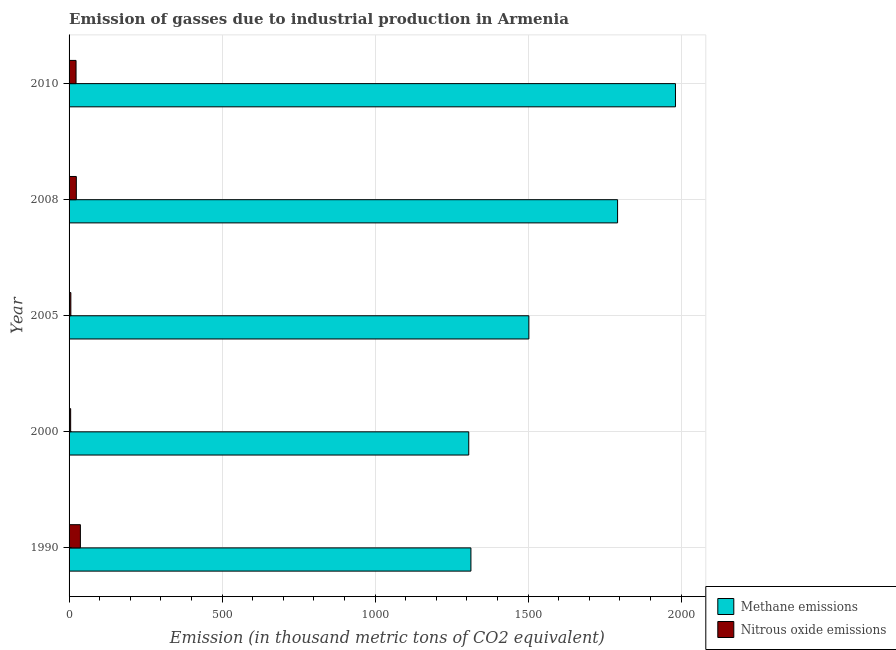How many different coloured bars are there?
Your answer should be compact. 2. Are the number of bars per tick equal to the number of legend labels?
Your answer should be compact. Yes. What is the label of the 2nd group of bars from the top?
Your answer should be very brief. 2008. In how many cases, is the number of bars for a given year not equal to the number of legend labels?
Offer a very short reply. 0. What is the amount of methane emissions in 2000?
Make the answer very short. 1306.1. Across all years, what is the maximum amount of methane emissions?
Keep it short and to the point. 1981.6. Across all years, what is the minimum amount of nitrous oxide emissions?
Give a very brief answer. 5.2. In which year was the amount of methane emissions minimum?
Offer a terse response. 2000. What is the total amount of methane emissions in the graph?
Ensure brevity in your answer.  7895.8. What is the difference between the amount of nitrous oxide emissions in 1990 and that in 2008?
Ensure brevity in your answer.  13.3. What is the difference between the amount of nitrous oxide emissions in 2005 and the amount of methane emissions in 2010?
Your response must be concise. -1975.8. What is the average amount of nitrous oxide emissions per year?
Your response must be concise. 18.9. In the year 2008, what is the difference between the amount of nitrous oxide emissions and amount of methane emissions?
Your response must be concise. -1768.7. What is the ratio of the amount of nitrous oxide emissions in 2008 to that in 2010?
Keep it short and to the point. 1.04. Is the difference between the amount of nitrous oxide emissions in 2000 and 2010 greater than the difference between the amount of methane emissions in 2000 and 2010?
Ensure brevity in your answer.  Yes. What is the difference between the highest and the second highest amount of nitrous oxide emissions?
Keep it short and to the point. 13.3. What is the difference between the highest and the lowest amount of methane emissions?
Give a very brief answer. 675.5. What does the 1st bar from the top in 2000 represents?
Give a very brief answer. Nitrous oxide emissions. What does the 1st bar from the bottom in 2005 represents?
Provide a succinct answer. Methane emissions. How many bars are there?
Your answer should be compact. 10. Are all the bars in the graph horizontal?
Your answer should be very brief. Yes. How many years are there in the graph?
Your answer should be compact. 5. Are the values on the major ticks of X-axis written in scientific E-notation?
Offer a terse response. No. Does the graph contain any zero values?
Your answer should be very brief. No. Does the graph contain grids?
Provide a succinct answer. Yes. Where does the legend appear in the graph?
Give a very brief answer. Bottom right. How many legend labels are there?
Offer a terse response. 2. How are the legend labels stacked?
Make the answer very short. Vertical. What is the title of the graph?
Your response must be concise. Emission of gasses due to industrial production in Armenia. Does "RDB concessional" appear as one of the legend labels in the graph?
Your answer should be compact. No. What is the label or title of the X-axis?
Provide a short and direct response. Emission (in thousand metric tons of CO2 equivalent). What is the label or title of the Y-axis?
Provide a short and direct response. Year. What is the Emission (in thousand metric tons of CO2 equivalent) of Methane emissions in 1990?
Keep it short and to the point. 1313.2. What is the Emission (in thousand metric tons of CO2 equivalent) in Methane emissions in 2000?
Provide a short and direct response. 1306.1. What is the Emission (in thousand metric tons of CO2 equivalent) of Methane emissions in 2005?
Offer a terse response. 1502.5. What is the Emission (in thousand metric tons of CO2 equivalent) of Methane emissions in 2008?
Provide a short and direct response. 1792.4. What is the Emission (in thousand metric tons of CO2 equivalent) of Nitrous oxide emissions in 2008?
Provide a short and direct response. 23.7. What is the Emission (in thousand metric tons of CO2 equivalent) of Methane emissions in 2010?
Make the answer very short. 1981.6. What is the Emission (in thousand metric tons of CO2 equivalent) in Nitrous oxide emissions in 2010?
Your answer should be very brief. 22.8. Across all years, what is the maximum Emission (in thousand metric tons of CO2 equivalent) of Methane emissions?
Your response must be concise. 1981.6. Across all years, what is the minimum Emission (in thousand metric tons of CO2 equivalent) in Methane emissions?
Offer a very short reply. 1306.1. Across all years, what is the minimum Emission (in thousand metric tons of CO2 equivalent) in Nitrous oxide emissions?
Offer a very short reply. 5.2. What is the total Emission (in thousand metric tons of CO2 equivalent) in Methane emissions in the graph?
Your answer should be very brief. 7895.8. What is the total Emission (in thousand metric tons of CO2 equivalent) in Nitrous oxide emissions in the graph?
Offer a terse response. 94.5. What is the difference between the Emission (in thousand metric tons of CO2 equivalent) of Methane emissions in 1990 and that in 2000?
Ensure brevity in your answer.  7.1. What is the difference between the Emission (in thousand metric tons of CO2 equivalent) in Nitrous oxide emissions in 1990 and that in 2000?
Keep it short and to the point. 31.8. What is the difference between the Emission (in thousand metric tons of CO2 equivalent) of Methane emissions in 1990 and that in 2005?
Your answer should be very brief. -189.3. What is the difference between the Emission (in thousand metric tons of CO2 equivalent) of Nitrous oxide emissions in 1990 and that in 2005?
Make the answer very short. 31.2. What is the difference between the Emission (in thousand metric tons of CO2 equivalent) of Methane emissions in 1990 and that in 2008?
Make the answer very short. -479.2. What is the difference between the Emission (in thousand metric tons of CO2 equivalent) of Methane emissions in 1990 and that in 2010?
Provide a short and direct response. -668.4. What is the difference between the Emission (in thousand metric tons of CO2 equivalent) of Nitrous oxide emissions in 1990 and that in 2010?
Give a very brief answer. 14.2. What is the difference between the Emission (in thousand metric tons of CO2 equivalent) in Methane emissions in 2000 and that in 2005?
Make the answer very short. -196.4. What is the difference between the Emission (in thousand metric tons of CO2 equivalent) in Methane emissions in 2000 and that in 2008?
Offer a very short reply. -486.3. What is the difference between the Emission (in thousand metric tons of CO2 equivalent) of Nitrous oxide emissions in 2000 and that in 2008?
Provide a succinct answer. -18.5. What is the difference between the Emission (in thousand metric tons of CO2 equivalent) in Methane emissions in 2000 and that in 2010?
Ensure brevity in your answer.  -675.5. What is the difference between the Emission (in thousand metric tons of CO2 equivalent) in Nitrous oxide emissions in 2000 and that in 2010?
Provide a succinct answer. -17.6. What is the difference between the Emission (in thousand metric tons of CO2 equivalent) of Methane emissions in 2005 and that in 2008?
Ensure brevity in your answer.  -289.9. What is the difference between the Emission (in thousand metric tons of CO2 equivalent) of Nitrous oxide emissions in 2005 and that in 2008?
Offer a terse response. -17.9. What is the difference between the Emission (in thousand metric tons of CO2 equivalent) in Methane emissions in 2005 and that in 2010?
Give a very brief answer. -479.1. What is the difference between the Emission (in thousand metric tons of CO2 equivalent) in Methane emissions in 2008 and that in 2010?
Your answer should be compact. -189.2. What is the difference between the Emission (in thousand metric tons of CO2 equivalent) in Methane emissions in 1990 and the Emission (in thousand metric tons of CO2 equivalent) in Nitrous oxide emissions in 2000?
Give a very brief answer. 1308. What is the difference between the Emission (in thousand metric tons of CO2 equivalent) in Methane emissions in 1990 and the Emission (in thousand metric tons of CO2 equivalent) in Nitrous oxide emissions in 2005?
Your answer should be very brief. 1307.4. What is the difference between the Emission (in thousand metric tons of CO2 equivalent) of Methane emissions in 1990 and the Emission (in thousand metric tons of CO2 equivalent) of Nitrous oxide emissions in 2008?
Provide a short and direct response. 1289.5. What is the difference between the Emission (in thousand metric tons of CO2 equivalent) of Methane emissions in 1990 and the Emission (in thousand metric tons of CO2 equivalent) of Nitrous oxide emissions in 2010?
Your answer should be compact. 1290.4. What is the difference between the Emission (in thousand metric tons of CO2 equivalent) of Methane emissions in 2000 and the Emission (in thousand metric tons of CO2 equivalent) of Nitrous oxide emissions in 2005?
Keep it short and to the point. 1300.3. What is the difference between the Emission (in thousand metric tons of CO2 equivalent) in Methane emissions in 2000 and the Emission (in thousand metric tons of CO2 equivalent) in Nitrous oxide emissions in 2008?
Your answer should be compact. 1282.4. What is the difference between the Emission (in thousand metric tons of CO2 equivalent) in Methane emissions in 2000 and the Emission (in thousand metric tons of CO2 equivalent) in Nitrous oxide emissions in 2010?
Keep it short and to the point. 1283.3. What is the difference between the Emission (in thousand metric tons of CO2 equivalent) of Methane emissions in 2005 and the Emission (in thousand metric tons of CO2 equivalent) of Nitrous oxide emissions in 2008?
Make the answer very short. 1478.8. What is the difference between the Emission (in thousand metric tons of CO2 equivalent) of Methane emissions in 2005 and the Emission (in thousand metric tons of CO2 equivalent) of Nitrous oxide emissions in 2010?
Give a very brief answer. 1479.7. What is the difference between the Emission (in thousand metric tons of CO2 equivalent) in Methane emissions in 2008 and the Emission (in thousand metric tons of CO2 equivalent) in Nitrous oxide emissions in 2010?
Ensure brevity in your answer.  1769.6. What is the average Emission (in thousand metric tons of CO2 equivalent) in Methane emissions per year?
Your answer should be very brief. 1579.16. In the year 1990, what is the difference between the Emission (in thousand metric tons of CO2 equivalent) in Methane emissions and Emission (in thousand metric tons of CO2 equivalent) in Nitrous oxide emissions?
Offer a very short reply. 1276.2. In the year 2000, what is the difference between the Emission (in thousand metric tons of CO2 equivalent) of Methane emissions and Emission (in thousand metric tons of CO2 equivalent) of Nitrous oxide emissions?
Your answer should be compact. 1300.9. In the year 2005, what is the difference between the Emission (in thousand metric tons of CO2 equivalent) in Methane emissions and Emission (in thousand metric tons of CO2 equivalent) in Nitrous oxide emissions?
Provide a succinct answer. 1496.7. In the year 2008, what is the difference between the Emission (in thousand metric tons of CO2 equivalent) of Methane emissions and Emission (in thousand metric tons of CO2 equivalent) of Nitrous oxide emissions?
Give a very brief answer. 1768.7. In the year 2010, what is the difference between the Emission (in thousand metric tons of CO2 equivalent) in Methane emissions and Emission (in thousand metric tons of CO2 equivalent) in Nitrous oxide emissions?
Offer a very short reply. 1958.8. What is the ratio of the Emission (in thousand metric tons of CO2 equivalent) in Methane emissions in 1990 to that in 2000?
Make the answer very short. 1.01. What is the ratio of the Emission (in thousand metric tons of CO2 equivalent) of Nitrous oxide emissions in 1990 to that in 2000?
Ensure brevity in your answer.  7.12. What is the ratio of the Emission (in thousand metric tons of CO2 equivalent) of Methane emissions in 1990 to that in 2005?
Provide a short and direct response. 0.87. What is the ratio of the Emission (in thousand metric tons of CO2 equivalent) in Nitrous oxide emissions in 1990 to that in 2005?
Your answer should be compact. 6.38. What is the ratio of the Emission (in thousand metric tons of CO2 equivalent) in Methane emissions in 1990 to that in 2008?
Ensure brevity in your answer.  0.73. What is the ratio of the Emission (in thousand metric tons of CO2 equivalent) in Nitrous oxide emissions in 1990 to that in 2008?
Give a very brief answer. 1.56. What is the ratio of the Emission (in thousand metric tons of CO2 equivalent) of Methane emissions in 1990 to that in 2010?
Make the answer very short. 0.66. What is the ratio of the Emission (in thousand metric tons of CO2 equivalent) in Nitrous oxide emissions in 1990 to that in 2010?
Make the answer very short. 1.62. What is the ratio of the Emission (in thousand metric tons of CO2 equivalent) of Methane emissions in 2000 to that in 2005?
Your answer should be compact. 0.87. What is the ratio of the Emission (in thousand metric tons of CO2 equivalent) of Nitrous oxide emissions in 2000 to that in 2005?
Offer a very short reply. 0.9. What is the ratio of the Emission (in thousand metric tons of CO2 equivalent) in Methane emissions in 2000 to that in 2008?
Offer a very short reply. 0.73. What is the ratio of the Emission (in thousand metric tons of CO2 equivalent) of Nitrous oxide emissions in 2000 to that in 2008?
Your response must be concise. 0.22. What is the ratio of the Emission (in thousand metric tons of CO2 equivalent) of Methane emissions in 2000 to that in 2010?
Offer a very short reply. 0.66. What is the ratio of the Emission (in thousand metric tons of CO2 equivalent) of Nitrous oxide emissions in 2000 to that in 2010?
Offer a terse response. 0.23. What is the ratio of the Emission (in thousand metric tons of CO2 equivalent) of Methane emissions in 2005 to that in 2008?
Provide a short and direct response. 0.84. What is the ratio of the Emission (in thousand metric tons of CO2 equivalent) of Nitrous oxide emissions in 2005 to that in 2008?
Your answer should be compact. 0.24. What is the ratio of the Emission (in thousand metric tons of CO2 equivalent) in Methane emissions in 2005 to that in 2010?
Your answer should be very brief. 0.76. What is the ratio of the Emission (in thousand metric tons of CO2 equivalent) of Nitrous oxide emissions in 2005 to that in 2010?
Give a very brief answer. 0.25. What is the ratio of the Emission (in thousand metric tons of CO2 equivalent) of Methane emissions in 2008 to that in 2010?
Your response must be concise. 0.9. What is the ratio of the Emission (in thousand metric tons of CO2 equivalent) of Nitrous oxide emissions in 2008 to that in 2010?
Ensure brevity in your answer.  1.04. What is the difference between the highest and the second highest Emission (in thousand metric tons of CO2 equivalent) of Methane emissions?
Give a very brief answer. 189.2. What is the difference between the highest and the second highest Emission (in thousand metric tons of CO2 equivalent) of Nitrous oxide emissions?
Provide a short and direct response. 13.3. What is the difference between the highest and the lowest Emission (in thousand metric tons of CO2 equivalent) of Methane emissions?
Give a very brief answer. 675.5. What is the difference between the highest and the lowest Emission (in thousand metric tons of CO2 equivalent) in Nitrous oxide emissions?
Provide a short and direct response. 31.8. 